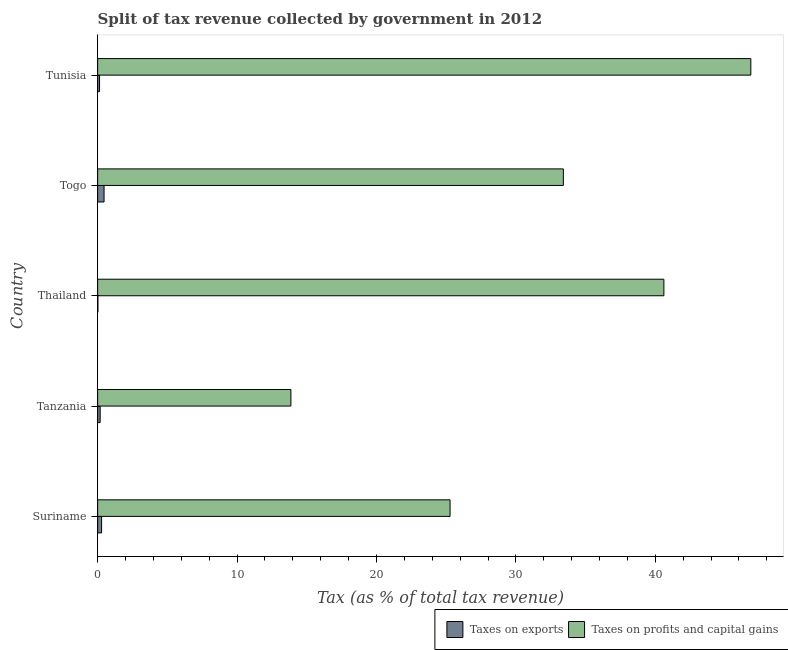How many groups of bars are there?
Provide a short and direct response. 5. Are the number of bars per tick equal to the number of legend labels?
Make the answer very short. Yes. What is the label of the 1st group of bars from the top?
Give a very brief answer. Tunisia. In how many cases, is the number of bars for a given country not equal to the number of legend labels?
Your answer should be very brief. 0. What is the percentage of revenue obtained from taxes on profits and capital gains in Tunisia?
Keep it short and to the point. 46.85. Across all countries, what is the maximum percentage of revenue obtained from taxes on profits and capital gains?
Provide a succinct answer. 46.85. Across all countries, what is the minimum percentage of revenue obtained from taxes on profits and capital gains?
Ensure brevity in your answer.  13.86. In which country was the percentage of revenue obtained from taxes on profits and capital gains maximum?
Make the answer very short. Tunisia. In which country was the percentage of revenue obtained from taxes on profits and capital gains minimum?
Give a very brief answer. Tanzania. What is the total percentage of revenue obtained from taxes on exports in the graph?
Keep it short and to the point. 1.08. What is the difference between the percentage of revenue obtained from taxes on profits and capital gains in Suriname and that in Togo?
Your answer should be compact. -8.12. What is the difference between the percentage of revenue obtained from taxes on profits and capital gains in Togo and the percentage of revenue obtained from taxes on exports in Thailand?
Make the answer very short. 33.39. What is the average percentage of revenue obtained from taxes on profits and capital gains per country?
Make the answer very short. 32. What is the difference between the percentage of revenue obtained from taxes on exports and percentage of revenue obtained from taxes on profits and capital gains in Tunisia?
Make the answer very short. -46.72. In how many countries, is the percentage of revenue obtained from taxes on exports greater than 4 %?
Your response must be concise. 0. What is the ratio of the percentage of revenue obtained from taxes on exports in Thailand to that in Tunisia?
Offer a terse response. 0.12. What is the difference between the highest and the second highest percentage of revenue obtained from taxes on exports?
Ensure brevity in your answer.  0.18. What is the difference between the highest and the lowest percentage of revenue obtained from taxes on exports?
Keep it short and to the point. 0.44. In how many countries, is the percentage of revenue obtained from taxes on exports greater than the average percentage of revenue obtained from taxes on exports taken over all countries?
Offer a terse response. 2. Is the sum of the percentage of revenue obtained from taxes on exports in Suriname and Thailand greater than the maximum percentage of revenue obtained from taxes on profits and capital gains across all countries?
Give a very brief answer. No. What does the 1st bar from the top in Tunisia represents?
Give a very brief answer. Taxes on profits and capital gains. What does the 2nd bar from the bottom in Suriname represents?
Your answer should be very brief. Taxes on profits and capital gains. How many bars are there?
Give a very brief answer. 10. How many countries are there in the graph?
Your answer should be compact. 5. What is the difference between two consecutive major ticks on the X-axis?
Ensure brevity in your answer.  10. Are the values on the major ticks of X-axis written in scientific E-notation?
Ensure brevity in your answer.  No. Does the graph contain any zero values?
Provide a short and direct response. No. Does the graph contain grids?
Give a very brief answer. No. How are the legend labels stacked?
Offer a very short reply. Horizontal. What is the title of the graph?
Offer a very short reply. Split of tax revenue collected by government in 2012. Does "Travel services" appear as one of the legend labels in the graph?
Provide a short and direct response. No. What is the label or title of the X-axis?
Provide a short and direct response. Tax (as % of total tax revenue). What is the label or title of the Y-axis?
Your answer should be compact. Country. What is the Tax (as % of total tax revenue) in Taxes on exports in Suriname?
Your response must be concise. 0.28. What is the Tax (as % of total tax revenue) in Taxes on profits and capital gains in Suriname?
Give a very brief answer. 25.28. What is the Tax (as % of total tax revenue) in Taxes on exports in Tanzania?
Give a very brief answer. 0.18. What is the Tax (as % of total tax revenue) of Taxes on profits and capital gains in Tanzania?
Offer a very short reply. 13.86. What is the Tax (as % of total tax revenue) of Taxes on exports in Thailand?
Ensure brevity in your answer.  0.02. What is the Tax (as % of total tax revenue) of Taxes on profits and capital gains in Thailand?
Give a very brief answer. 40.61. What is the Tax (as % of total tax revenue) in Taxes on exports in Togo?
Make the answer very short. 0.46. What is the Tax (as % of total tax revenue) of Taxes on profits and capital gains in Togo?
Your answer should be compact. 33.4. What is the Tax (as % of total tax revenue) of Taxes on exports in Tunisia?
Your answer should be compact. 0.14. What is the Tax (as % of total tax revenue) in Taxes on profits and capital gains in Tunisia?
Make the answer very short. 46.85. Across all countries, what is the maximum Tax (as % of total tax revenue) in Taxes on exports?
Make the answer very short. 0.46. Across all countries, what is the maximum Tax (as % of total tax revenue) in Taxes on profits and capital gains?
Your answer should be compact. 46.85. Across all countries, what is the minimum Tax (as % of total tax revenue) of Taxes on exports?
Ensure brevity in your answer.  0.02. Across all countries, what is the minimum Tax (as % of total tax revenue) in Taxes on profits and capital gains?
Your response must be concise. 13.86. What is the total Tax (as % of total tax revenue) of Taxes on exports in the graph?
Make the answer very short. 1.08. What is the total Tax (as % of total tax revenue) in Taxes on profits and capital gains in the graph?
Provide a short and direct response. 160.01. What is the difference between the Tax (as % of total tax revenue) of Taxes on exports in Suriname and that in Tanzania?
Offer a very short reply. 0.1. What is the difference between the Tax (as % of total tax revenue) of Taxes on profits and capital gains in Suriname and that in Tanzania?
Offer a terse response. 11.42. What is the difference between the Tax (as % of total tax revenue) of Taxes on exports in Suriname and that in Thailand?
Give a very brief answer. 0.27. What is the difference between the Tax (as % of total tax revenue) in Taxes on profits and capital gains in Suriname and that in Thailand?
Offer a terse response. -15.34. What is the difference between the Tax (as % of total tax revenue) in Taxes on exports in Suriname and that in Togo?
Offer a very short reply. -0.18. What is the difference between the Tax (as % of total tax revenue) in Taxes on profits and capital gains in Suriname and that in Togo?
Give a very brief answer. -8.13. What is the difference between the Tax (as % of total tax revenue) in Taxes on exports in Suriname and that in Tunisia?
Provide a short and direct response. 0.15. What is the difference between the Tax (as % of total tax revenue) in Taxes on profits and capital gains in Suriname and that in Tunisia?
Your answer should be compact. -21.57. What is the difference between the Tax (as % of total tax revenue) of Taxes on exports in Tanzania and that in Thailand?
Make the answer very short. 0.16. What is the difference between the Tax (as % of total tax revenue) of Taxes on profits and capital gains in Tanzania and that in Thailand?
Offer a terse response. -26.75. What is the difference between the Tax (as % of total tax revenue) of Taxes on exports in Tanzania and that in Togo?
Offer a terse response. -0.28. What is the difference between the Tax (as % of total tax revenue) of Taxes on profits and capital gains in Tanzania and that in Togo?
Offer a terse response. -19.54. What is the difference between the Tax (as % of total tax revenue) of Taxes on exports in Tanzania and that in Tunisia?
Make the answer very short. 0.04. What is the difference between the Tax (as % of total tax revenue) in Taxes on profits and capital gains in Tanzania and that in Tunisia?
Offer a terse response. -32.99. What is the difference between the Tax (as % of total tax revenue) in Taxes on exports in Thailand and that in Togo?
Ensure brevity in your answer.  -0.44. What is the difference between the Tax (as % of total tax revenue) in Taxes on profits and capital gains in Thailand and that in Togo?
Offer a very short reply. 7.21. What is the difference between the Tax (as % of total tax revenue) of Taxes on exports in Thailand and that in Tunisia?
Offer a terse response. -0.12. What is the difference between the Tax (as % of total tax revenue) of Taxes on profits and capital gains in Thailand and that in Tunisia?
Ensure brevity in your answer.  -6.24. What is the difference between the Tax (as % of total tax revenue) of Taxes on exports in Togo and that in Tunisia?
Keep it short and to the point. 0.32. What is the difference between the Tax (as % of total tax revenue) in Taxes on profits and capital gains in Togo and that in Tunisia?
Keep it short and to the point. -13.45. What is the difference between the Tax (as % of total tax revenue) in Taxes on exports in Suriname and the Tax (as % of total tax revenue) in Taxes on profits and capital gains in Tanzania?
Your response must be concise. -13.58. What is the difference between the Tax (as % of total tax revenue) of Taxes on exports in Suriname and the Tax (as % of total tax revenue) of Taxes on profits and capital gains in Thailand?
Provide a succinct answer. -40.33. What is the difference between the Tax (as % of total tax revenue) of Taxes on exports in Suriname and the Tax (as % of total tax revenue) of Taxes on profits and capital gains in Togo?
Provide a succinct answer. -33.12. What is the difference between the Tax (as % of total tax revenue) in Taxes on exports in Suriname and the Tax (as % of total tax revenue) in Taxes on profits and capital gains in Tunisia?
Your response must be concise. -46.57. What is the difference between the Tax (as % of total tax revenue) in Taxes on exports in Tanzania and the Tax (as % of total tax revenue) in Taxes on profits and capital gains in Thailand?
Keep it short and to the point. -40.43. What is the difference between the Tax (as % of total tax revenue) in Taxes on exports in Tanzania and the Tax (as % of total tax revenue) in Taxes on profits and capital gains in Togo?
Your answer should be very brief. -33.22. What is the difference between the Tax (as % of total tax revenue) of Taxes on exports in Tanzania and the Tax (as % of total tax revenue) of Taxes on profits and capital gains in Tunisia?
Provide a short and direct response. -46.67. What is the difference between the Tax (as % of total tax revenue) in Taxes on exports in Thailand and the Tax (as % of total tax revenue) in Taxes on profits and capital gains in Togo?
Provide a succinct answer. -33.39. What is the difference between the Tax (as % of total tax revenue) of Taxes on exports in Thailand and the Tax (as % of total tax revenue) of Taxes on profits and capital gains in Tunisia?
Provide a succinct answer. -46.83. What is the difference between the Tax (as % of total tax revenue) of Taxes on exports in Togo and the Tax (as % of total tax revenue) of Taxes on profits and capital gains in Tunisia?
Offer a terse response. -46.39. What is the average Tax (as % of total tax revenue) in Taxes on exports per country?
Give a very brief answer. 0.22. What is the average Tax (as % of total tax revenue) of Taxes on profits and capital gains per country?
Keep it short and to the point. 32. What is the difference between the Tax (as % of total tax revenue) in Taxes on exports and Tax (as % of total tax revenue) in Taxes on profits and capital gains in Suriname?
Offer a terse response. -24.99. What is the difference between the Tax (as % of total tax revenue) of Taxes on exports and Tax (as % of total tax revenue) of Taxes on profits and capital gains in Tanzania?
Your answer should be compact. -13.68. What is the difference between the Tax (as % of total tax revenue) of Taxes on exports and Tax (as % of total tax revenue) of Taxes on profits and capital gains in Thailand?
Offer a terse response. -40.6. What is the difference between the Tax (as % of total tax revenue) of Taxes on exports and Tax (as % of total tax revenue) of Taxes on profits and capital gains in Togo?
Provide a short and direct response. -32.94. What is the difference between the Tax (as % of total tax revenue) in Taxes on exports and Tax (as % of total tax revenue) in Taxes on profits and capital gains in Tunisia?
Offer a terse response. -46.71. What is the ratio of the Tax (as % of total tax revenue) in Taxes on exports in Suriname to that in Tanzania?
Provide a succinct answer. 1.56. What is the ratio of the Tax (as % of total tax revenue) in Taxes on profits and capital gains in Suriname to that in Tanzania?
Offer a terse response. 1.82. What is the ratio of the Tax (as % of total tax revenue) of Taxes on exports in Suriname to that in Thailand?
Your answer should be compact. 16.59. What is the ratio of the Tax (as % of total tax revenue) of Taxes on profits and capital gains in Suriname to that in Thailand?
Give a very brief answer. 0.62. What is the ratio of the Tax (as % of total tax revenue) in Taxes on exports in Suriname to that in Togo?
Keep it short and to the point. 0.62. What is the ratio of the Tax (as % of total tax revenue) of Taxes on profits and capital gains in Suriname to that in Togo?
Offer a very short reply. 0.76. What is the ratio of the Tax (as % of total tax revenue) in Taxes on exports in Suriname to that in Tunisia?
Offer a terse response. 2.07. What is the ratio of the Tax (as % of total tax revenue) in Taxes on profits and capital gains in Suriname to that in Tunisia?
Provide a succinct answer. 0.54. What is the ratio of the Tax (as % of total tax revenue) of Taxes on exports in Tanzania to that in Thailand?
Your response must be concise. 10.6. What is the ratio of the Tax (as % of total tax revenue) of Taxes on profits and capital gains in Tanzania to that in Thailand?
Keep it short and to the point. 0.34. What is the ratio of the Tax (as % of total tax revenue) of Taxes on exports in Tanzania to that in Togo?
Your answer should be very brief. 0.39. What is the ratio of the Tax (as % of total tax revenue) of Taxes on profits and capital gains in Tanzania to that in Togo?
Make the answer very short. 0.41. What is the ratio of the Tax (as % of total tax revenue) in Taxes on exports in Tanzania to that in Tunisia?
Your answer should be compact. 1.33. What is the ratio of the Tax (as % of total tax revenue) in Taxes on profits and capital gains in Tanzania to that in Tunisia?
Make the answer very short. 0.3. What is the ratio of the Tax (as % of total tax revenue) of Taxes on exports in Thailand to that in Togo?
Your response must be concise. 0.04. What is the ratio of the Tax (as % of total tax revenue) in Taxes on profits and capital gains in Thailand to that in Togo?
Keep it short and to the point. 1.22. What is the ratio of the Tax (as % of total tax revenue) of Taxes on exports in Thailand to that in Tunisia?
Ensure brevity in your answer.  0.12. What is the ratio of the Tax (as % of total tax revenue) of Taxes on profits and capital gains in Thailand to that in Tunisia?
Your response must be concise. 0.87. What is the ratio of the Tax (as % of total tax revenue) in Taxes on exports in Togo to that in Tunisia?
Keep it short and to the point. 3.36. What is the ratio of the Tax (as % of total tax revenue) in Taxes on profits and capital gains in Togo to that in Tunisia?
Provide a short and direct response. 0.71. What is the difference between the highest and the second highest Tax (as % of total tax revenue) in Taxes on exports?
Keep it short and to the point. 0.18. What is the difference between the highest and the second highest Tax (as % of total tax revenue) in Taxes on profits and capital gains?
Offer a terse response. 6.24. What is the difference between the highest and the lowest Tax (as % of total tax revenue) in Taxes on exports?
Provide a succinct answer. 0.44. What is the difference between the highest and the lowest Tax (as % of total tax revenue) in Taxes on profits and capital gains?
Your response must be concise. 32.99. 